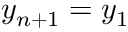Convert formula to latex. <formula><loc_0><loc_0><loc_500><loc_500>y _ { n + 1 } = y _ { 1 }</formula> 